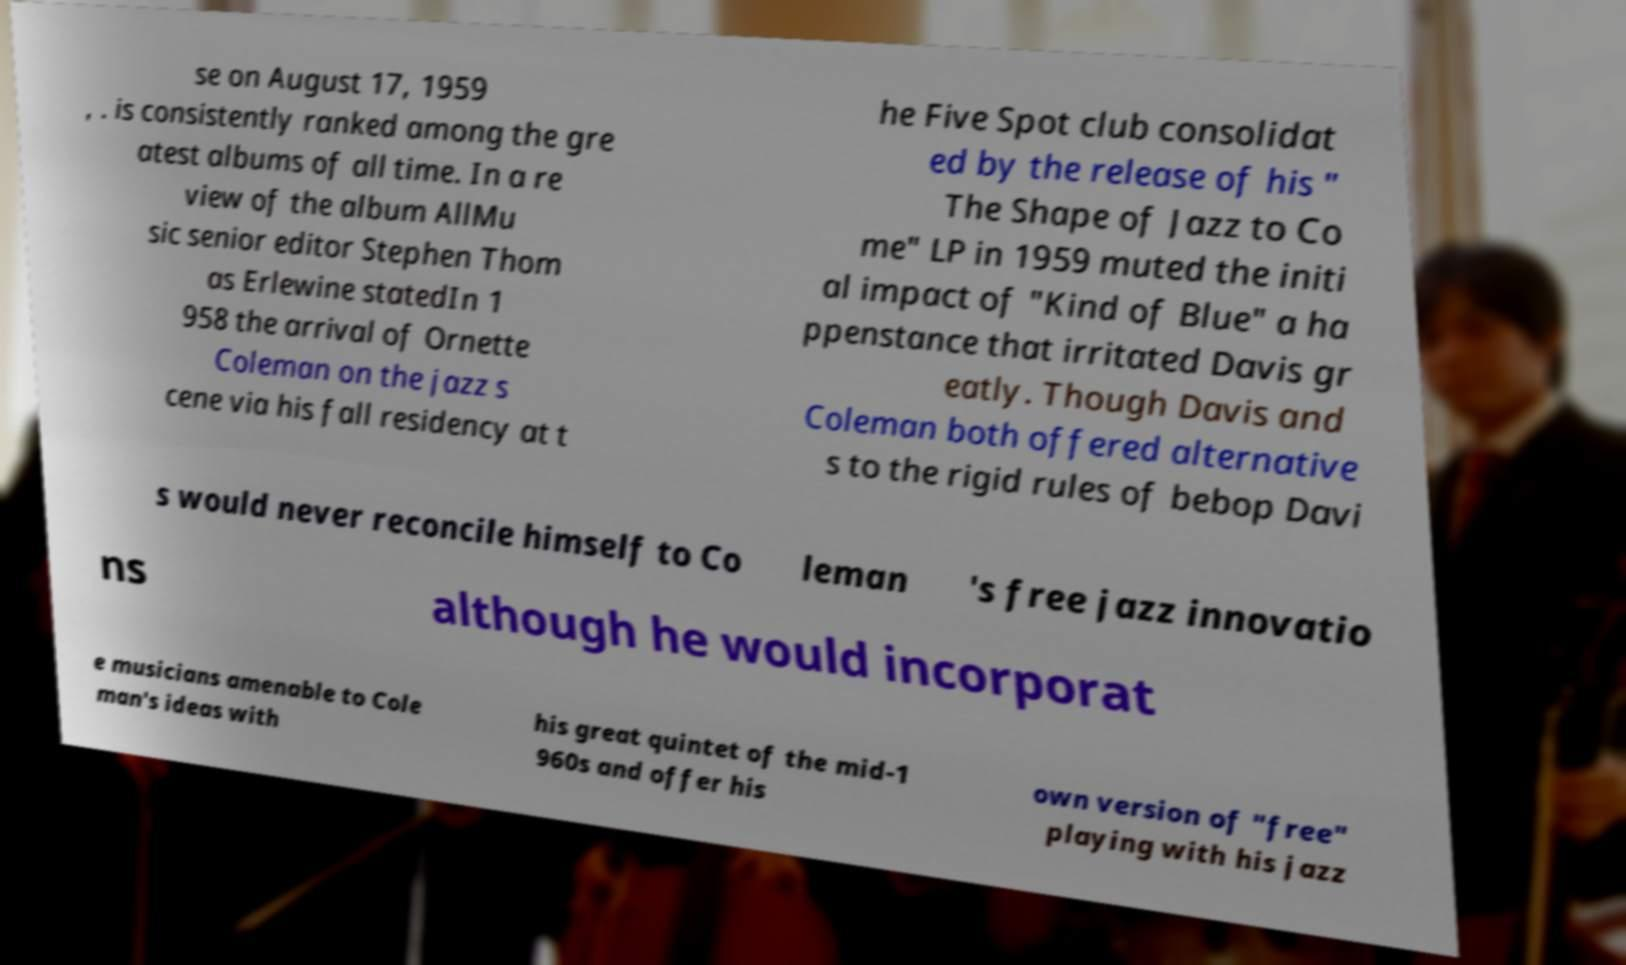There's text embedded in this image that I need extracted. Can you transcribe it verbatim? se on August 17, 1959 , . is consistently ranked among the gre atest albums of all time. In a re view of the album AllMu sic senior editor Stephen Thom as Erlewine statedIn 1 958 the arrival of Ornette Coleman on the jazz s cene via his fall residency at t he Five Spot club consolidat ed by the release of his " The Shape of Jazz to Co me" LP in 1959 muted the initi al impact of "Kind of Blue" a ha ppenstance that irritated Davis gr eatly. Though Davis and Coleman both offered alternative s to the rigid rules of bebop Davi s would never reconcile himself to Co leman 's free jazz innovatio ns although he would incorporat e musicians amenable to Cole man's ideas with his great quintet of the mid-1 960s and offer his own version of "free" playing with his jazz 